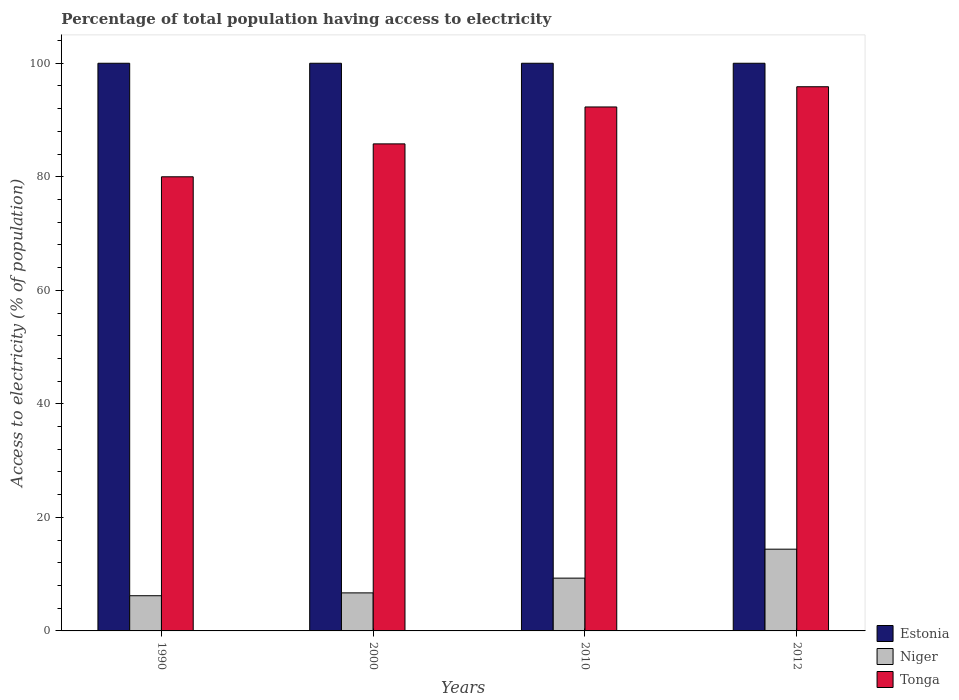How many different coloured bars are there?
Ensure brevity in your answer.  3. Are the number of bars on each tick of the X-axis equal?
Offer a terse response. Yes. How many bars are there on the 4th tick from the right?
Provide a short and direct response. 3. What is the label of the 2nd group of bars from the left?
Give a very brief answer. 2000. In how many cases, is the number of bars for a given year not equal to the number of legend labels?
Make the answer very short. 0. What is the percentage of population that have access to electricity in Tonga in 2012?
Provide a succinct answer. 95.86. Across all years, what is the maximum percentage of population that have access to electricity in Niger?
Keep it short and to the point. 14.4. Across all years, what is the minimum percentage of population that have access to electricity in Tonga?
Keep it short and to the point. 80. In which year was the percentage of population that have access to electricity in Tonga minimum?
Your response must be concise. 1990. What is the total percentage of population that have access to electricity in Niger in the graph?
Your response must be concise. 36.6. What is the difference between the percentage of population that have access to electricity in Tonga in 1990 and that in 2000?
Provide a succinct answer. -5.8. What is the difference between the percentage of population that have access to electricity in Estonia in 2012 and the percentage of population that have access to electricity in Niger in 1990?
Offer a terse response. 93.8. What is the average percentage of population that have access to electricity in Tonga per year?
Provide a succinct answer. 88.49. In the year 2000, what is the difference between the percentage of population that have access to electricity in Estonia and percentage of population that have access to electricity in Tonga?
Offer a terse response. 14.2. In how many years, is the percentage of population that have access to electricity in Niger greater than 84 %?
Keep it short and to the point. 0. What is the ratio of the percentage of population that have access to electricity in Niger in 2000 to that in 2010?
Your answer should be compact. 0.72. Is the percentage of population that have access to electricity in Niger in 2000 less than that in 2012?
Make the answer very short. Yes. Is the difference between the percentage of population that have access to electricity in Estonia in 2000 and 2010 greater than the difference between the percentage of population that have access to electricity in Tonga in 2000 and 2010?
Your response must be concise. Yes. What is the difference between the highest and the second highest percentage of population that have access to electricity in Tonga?
Your response must be concise. 3.56. What is the difference between the highest and the lowest percentage of population that have access to electricity in Tonga?
Offer a terse response. 15.86. In how many years, is the percentage of population that have access to electricity in Tonga greater than the average percentage of population that have access to electricity in Tonga taken over all years?
Keep it short and to the point. 2. Is the sum of the percentage of population that have access to electricity in Tonga in 2000 and 2010 greater than the maximum percentage of population that have access to electricity in Estonia across all years?
Make the answer very short. Yes. What does the 1st bar from the left in 1990 represents?
Offer a very short reply. Estonia. What does the 3rd bar from the right in 2000 represents?
Provide a succinct answer. Estonia. How many bars are there?
Provide a short and direct response. 12. What is the difference between two consecutive major ticks on the Y-axis?
Your answer should be compact. 20. Are the values on the major ticks of Y-axis written in scientific E-notation?
Your response must be concise. No. Does the graph contain grids?
Provide a short and direct response. No. How many legend labels are there?
Give a very brief answer. 3. How are the legend labels stacked?
Keep it short and to the point. Vertical. What is the title of the graph?
Provide a succinct answer. Percentage of total population having access to electricity. What is the label or title of the X-axis?
Offer a terse response. Years. What is the label or title of the Y-axis?
Offer a terse response. Access to electricity (% of population). What is the Access to electricity (% of population) of Estonia in 1990?
Provide a short and direct response. 100. What is the Access to electricity (% of population) in Niger in 1990?
Your answer should be very brief. 6.2. What is the Access to electricity (% of population) in Tonga in 1990?
Offer a very short reply. 80. What is the Access to electricity (% of population) in Estonia in 2000?
Make the answer very short. 100. What is the Access to electricity (% of population) of Tonga in 2000?
Your answer should be compact. 85.8. What is the Access to electricity (% of population) in Niger in 2010?
Keep it short and to the point. 9.3. What is the Access to electricity (% of population) of Tonga in 2010?
Your answer should be compact. 92.3. What is the Access to electricity (% of population) of Niger in 2012?
Give a very brief answer. 14.4. What is the Access to electricity (% of population) of Tonga in 2012?
Provide a succinct answer. 95.86. Across all years, what is the maximum Access to electricity (% of population) of Tonga?
Your response must be concise. 95.86. Across all years, what is the minimum Access to electricity (% of population) of Estonia?
Your response must be concise. 100. Across all years, what is the minimum Access to electricity (% of population) of Tonga?
Give a very brief answer. 80. What is the total Access to electricity (% of population) of Niger in the graph?
Your answer should be compact. 36.6. What is the total Access to electricity (% of population) of Tonga in the graph?
Make the answer very short. 353.96. What is the difference between the Access to electricity (% of population) of Estonia in 1990 and that in 2000?
Give a very brief answer. 0. What is the difference between the Access to electricity (% of population) in Niger in 1990 and that in 2000?
Offer a terse response. -0.5. What is the difference between the Access to electricity (% of population) in Tonga in 1990 and that in 2000?
Keep it short and to the point. -5.8. What is the difference between the Access to electricity (% of population) of Tonga in 1990 and that in 2010?
Your answer should be compact. -12.3. What is the difference between the Access to electricity (% of population) of Estonia in 1990 and that in 2012?
Give a very brief answer. 0. What is the difference between the Access to electricity (% of population) of Tonga in 1990 and that in 2012?
Provide a succinct answer. -15.86. What is the difference between the Access to electricity (% of population) of Estonia in 2000 and that in 2010?
Offer a terse response. 0. What is the difference between the Access to electricity (% of population) of Niger in 2000 and that in 2010?
Offer a very short reply. -2.6. What is the difference between the Access to electricity (% of population) of Tonga in 2000 and that in 2010?
Ensure brevity in your answer.  -6.5. What is the difference between the Access to electricity (% of population) in Niger in 2000 and that in 2012?
Offer a very short reply. -7.7. What is the difference between the Access to electricity (% of population) in Tonga in 2000 and that in 2012?
Your answer should be very brief. -10.06. What is the difference between the Access to electricity (% of population) in Niger in 2010 and that in 2012?
Your answer should be very brief. -5.1. What is the difference between the Access to electricity (% of population) of Tonga in 2010 and that in 2012?
Offer a very short reply. -3.56. What is the difference between the Access to electricity (% of population) in Estonia in 1990 and the Access to electricity (% of population) in Niger in 2000?
Ensure brevity in your answer.  93.3. What is the difference between the Access to electricity (% of population) in Estonia in 1990 and the Access to electricity (% of population) in Tonga in 2000?
Your response must be concise. 14.2. What is the difference between the Access to electricity (% of population) of Niger in 1990 and the Access to electricity (% of population) of Tonga in 2000?
Keep it short and to the point. -79.6. What is the difference between the Access to electricity (% of population) of Estonia in 1990 and the Access to electricity (% of population) of Niger in 2010?
Provide a short and direct response. 90.7. What is the difference between the Access to electricity (% of population) in Niger in 1990 and the Access to electricity (% of population) in Tonga in 2010?
Your answer should be very brief. -86.1. What is the difference between the Access to electricity (% of population) of Estonia in 1990 and the Access to electricity (% of population) of Niger in 2012?
Give a very brief answer. 85.6. What is the difference between the Access to electricity (% of population) in Estonia in 1990 and the Access to electricity (% of population) in Tonga in 2012?
Offer a very short reply. 4.14. What is the difference between the Access to electricity (% of population) of Niger in 1990 and the Access to electricity (% of population) of Tonga in 2012?
Your response must be concise. -89.66. What is the difference between the Access to electricity (% of population) of Estonia in 2000 and the Access to electricity (% of population) of Niger in 2010?
Keep it short and to the point. 90.7. What is the difference between the Access to electricity (% of population) of Niger in 2000 and the Access to electricity (% of population) of Tonga in 2010?
Your answer should be very brief. -85.6. What is the difference between the Access to electricity (% of population) in Estonia in 2000 and the Access to electricity (% of population) in Niger in 2012?
Give a very brief answer. 85.6. What is the difference between the Access to electricity (% of population) in Estonia in 2000 and the Access to electricity (% of population) in Tonga in 2012?
Your answer should be compact. 4.14. What is the difference between the Access to electricity (% of population) of Niger in 2000 and the Access to electricity (% of population) of Tonga in 2012?
Ensure brevity in your answer.  -89.16. What is the difference between the Access to electricity (% of population) in Estonia in 2010 and the Access to electricity (% of population) in Niger in 2012?
Give a very brief answer. 85.6. What is the difference between the Access to electricity (% of population) in Estonia in 2010 and the Access to electricity (% of population) in Tonga in 2012?
Your answer should be very brief. 4.14. What is the difference between the Access to electricity (% of population) of Niger in 2010 and the Access to electricity (% of population) of Tonga in 2012?
Your answer should be very brief. -86.56. What is the average Access to electricity (% of population) in Estonia per year?
Ensure brevity in your answer.  100. What is the average Access to electricity (% of population) of Niger per year?
Offer a very short reply. 9.15. What is the average Access to electricity (% of population) of Tonga per year?
Your response must be concise. 88.49. In the year 1990, what is the difference between the Access to electricity (% of population) in Estonia and Access to electricity (% of population) in Niger?
Make the answer very short. 93.8. In the year 1990, what is the difference between the Access to electricity (% of population) of Niger and Access to electricity (% of population) of Tonga?
Ensure brevity in your answer.  -73.8. In the year 2000, what is the difference between the Access to electricity (% of population) of Estonia and Access to electricity (% of population) of Niger?
Keep it short and to the point. 93.3. In the year 2000, what is the difference between the Access to electricity (% of population) of Estonia and Access to electricity (% of population) of Tonga?
Provide a short and direct response. 14.2. In the year 2000, what is the difference between the Access to electricity (% of population) of Niger and Access to electricity (% of population) of Tonga?
Give a very brief answer. -79.1. In the year 2010, what is the difference between the Access to electricity (% of population) in Estonia and Access to electricity (% of population) in Niger?
Ensure brevity in your answer.  90.7. In the year 2010, what is the difference between the Access to electricity (% of population) in Niger and Access to electricity (% of population) in Tonga?
Your response must be concise. -83. In the year 2012, what is the difference between the Access to electricity (% of population) in Estonia and Access to electricity (% of population) in Niger?
Your answer should be very brief. 85.6. In the year 2012, what is the difference between the Access to electricity (% of population) of Estonia and Access to electricity (% of population) of Tonga?
Make the answer very short. 4.14. In the year 2012, what is the difference between the Access to electricity (% of population) in Niger and Access to electricity (% of population) in Tonga?
Provide a short and direct response. -81.46. What is the ratio of the Access to electricity (% of population) in Niger in 1990 to that in 2000?
Your answer should be very brief. 0.93. What is the ratio of the Access to electricity (% of population) of Tonga in 1990 to that in 2000?
Offer a very short reply. 0.93. What is the ratio of the Access to electricity (% of population) in Niger in 1990 to that in 2010?
Make the answer very short. 0.67. What is the ratio of the Access to electricity (% of population) in Tonga in 1990 to that in 2010?
Your response must be concise. 0.87. What is the ratio of the Access to electricity (% of population) in Estonia in 1990 to that in 2012?
Keep it short and to the point. 1. What is the ratio of the Access to electricity (% of population) of Niger in 1990 to that in 2012?
Your answer should be very brief. 0.43. What is the ratio of the Access to electricity (% of population) in Tonga in 1990 to that in 2012?
Ensure brevity in your answer.  0.83. What is the ratio of the Access to electricity (% of population) in Estonia in 2000 to that in 2010?
Offer a very short reply. 1. What is the ratio of the Access to electricity (% of population) in Niger in 2000 to that in 2010?
Your answer should be compact. 0.72. What is the ratio of the Access to electricity (% of population) of Tonga in 2000 to that in 2010?
Make the answer very short. 0.93. What is the ratio of the Access to electricity (% of population) in Estonia in 2000 to that in 2012?
Your answer should be very brief. 1. What is the ratio of the Access to electricity (% of population) in Niger in 2000 to that in 2012?
Provide a succinct answer. 0.47. What is the ratio of the Access to electricity (% of population) of Tonga in 2000 to that in 2012?
Your answer should be very brief. 0.9. What is the ratio of the Access to electricity (% of population) in Niger in 2010 to that in 2012?
Your answer should be compact. 0.65. What is the ratio of the Access to electricity (% of population) in Tonga in 2010 to that in 2012?
Keep it short and to the point. 0.96. What is the difference between the highest and the second highest Access to electricity (% of population) in Tonga?
Ensure brevity in your answer.  3.56. What is the difference between the highest and the lowest Access to electricity (% of population) in Estonia?
Your response must be concise. 0. What is the difference between the highest and the lowest Access to electricity (% of population) in Tonga?
Provide a succinct answer. 15.86. 